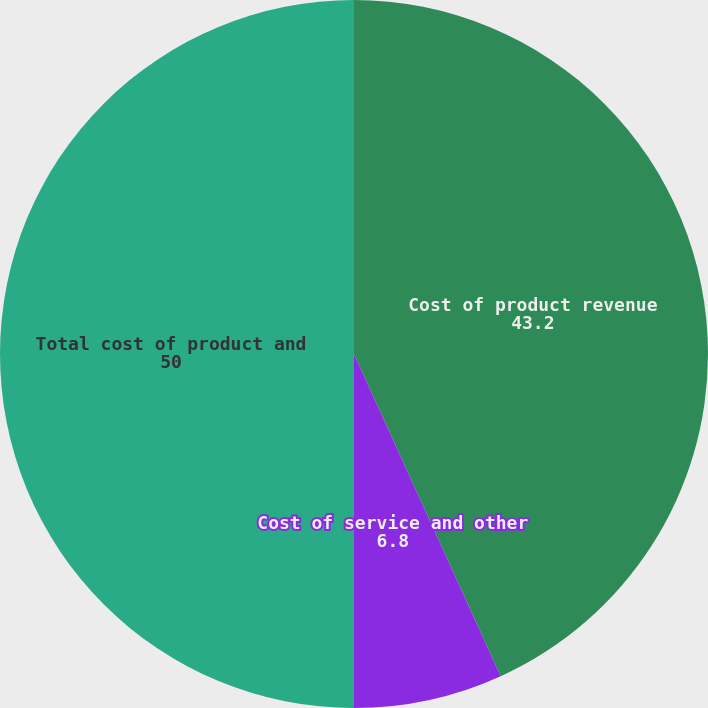Convert chart. <chart><loc_0><loc_0><loc_500><loc_500><pie_chart><fcel>Cost of product revenue<fcel>Cost of service and other<fcel>Total cost of product and<nl><fcel>43.2%<fcel>6.8%<fcel>50.0%<nl></chart> 